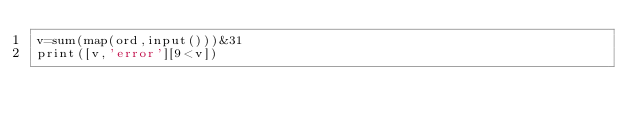Convert code to text. <code><loc_0><loc_0><loc_500><loc_500><_Cython_>v=sum(map(ord,input()))&31
print([v,'error'][9<v])</code> 